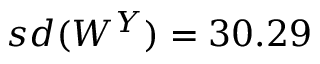<formula> <loc_0><loc_0><loc_500><loc_500>s d ( W ^ { Y } ) = 3 0 . 2 9</formula> 